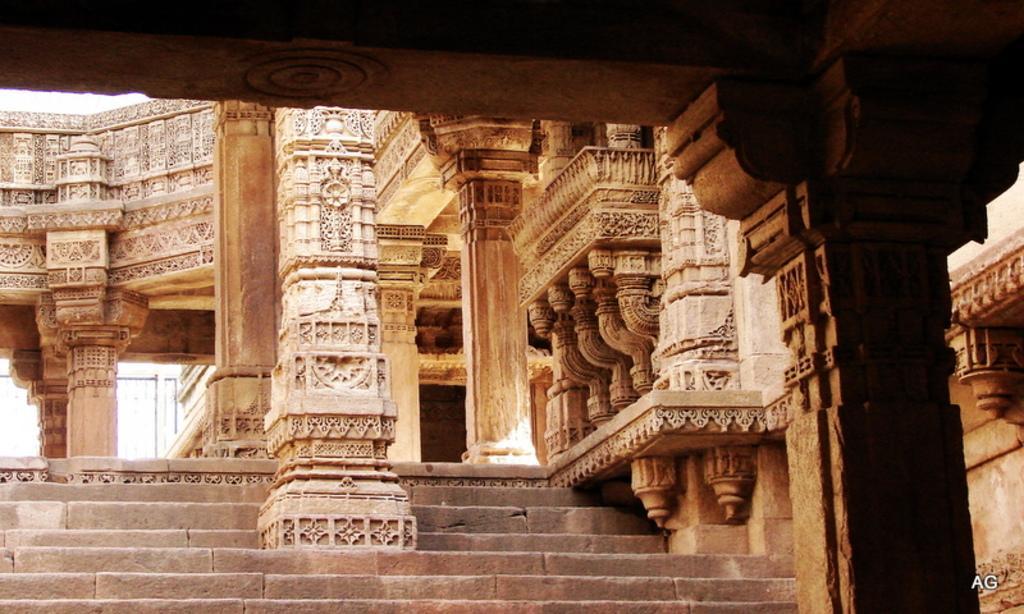How would you summarize this image in a sentence or two? This looks like an ancient architectural building. I can see the sculptures on the walls and pillars. These are the stairs. At the bottom right side of the image, I can see the watermark. 